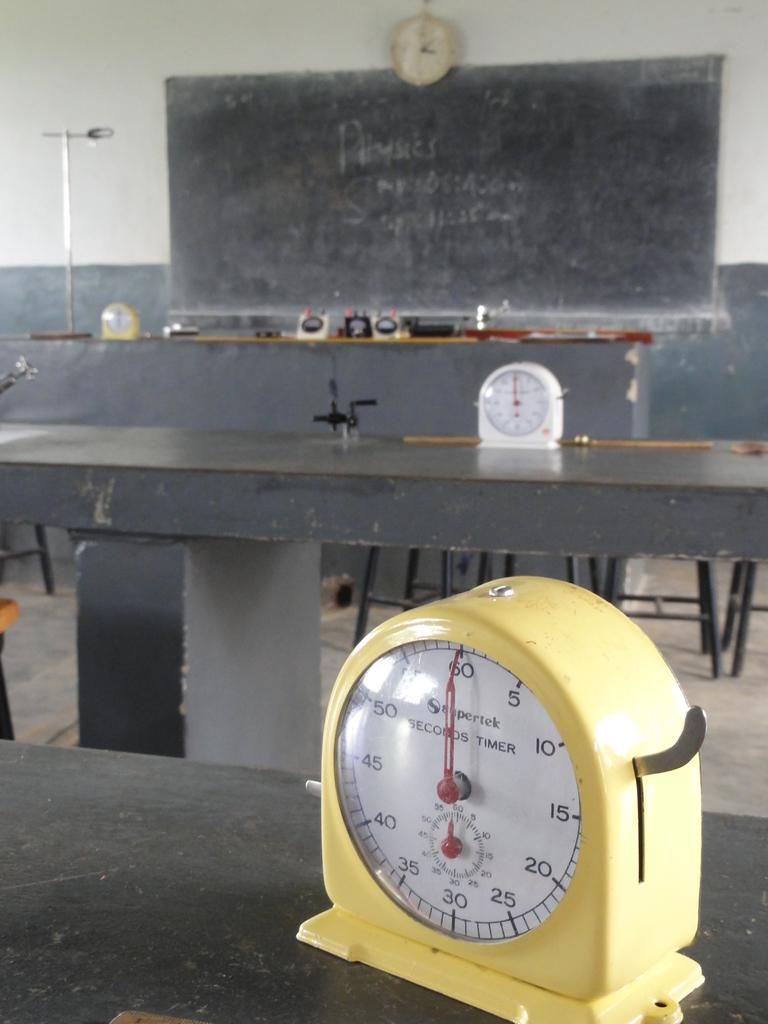<image>
Render a clear and concise summary of the photo. A classroom with clocks on the tables and a blackboard that says Physics. 